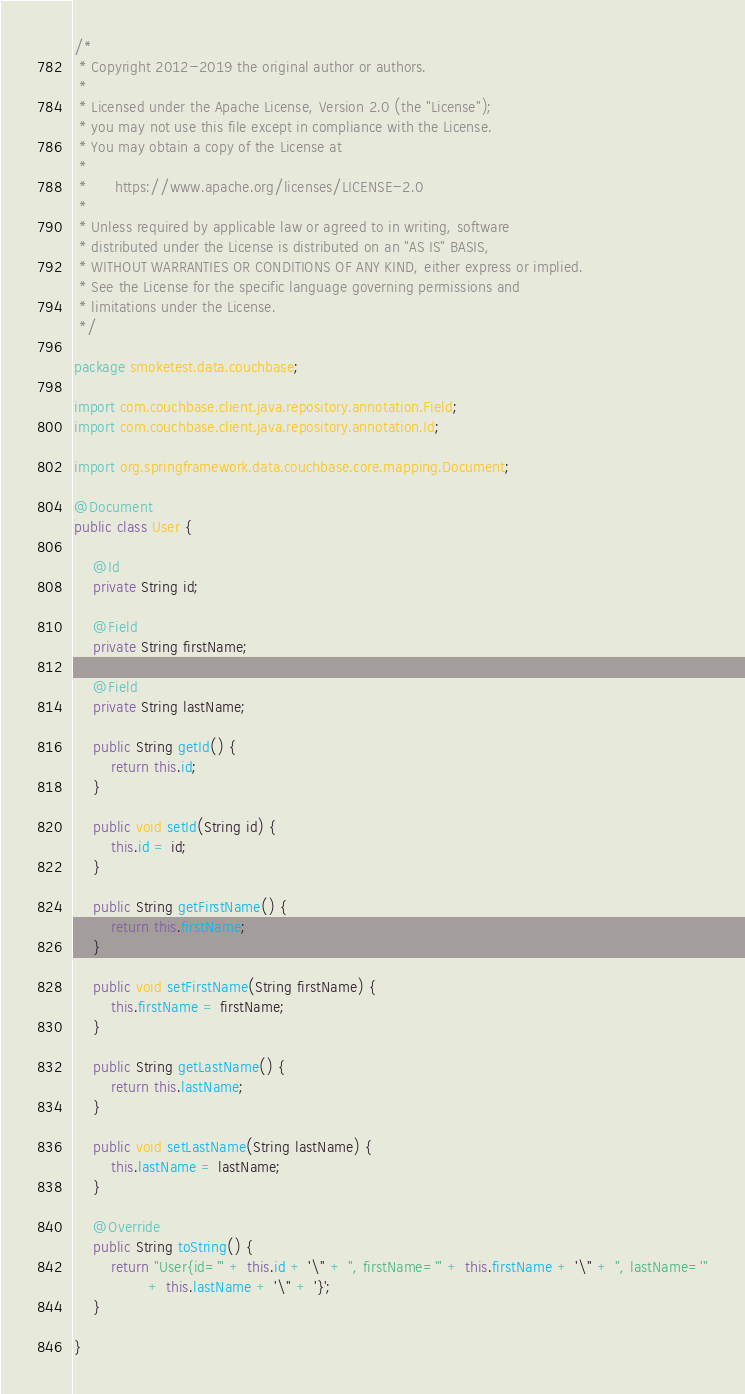<code> <loc_0><loc_0><loc_500><loc_500><_Java_>/*
 * Copyright 2012-2019 the original author or authors.
 *
 * Licensed under the Apache License, Version 2.0 (the "License");
 * you may not use this file except in compliance with the License.
 * You may obtain a copy of the License at
 *
 *      https://www.apache.org/licenses/LICENSE-2.0
 *
 * Unless required by applicable law or agreed to in writing, software
 * distributed under the License is distributed on an "AS IS" BASIS,
 * WITHOUT WARRANTIES OR CONDITIONS OF ANY KIND, either express or implied.
 * See the License for the specific language governing permissions and
 * limitations under the License.
 */

package smoketest.data.couchbase;

import com.couchbase.client.java.repository.annotation.Field;
import com.couchbase.client.java.repository.annotation.Id;

import org.springframework.data.couchbase.core.mapping.Document;

@Document
public class User {

	@Id
	private String id;

	@Field
	private String firstName;

	@Field
	private String lastName;

	public String getId() {
		return this.id;
	}

	public void setId(String id) {
		this.id = id;
	}

	public String getFirstName() {
		return this.firstName;
	}

	public void setFirstName(String firstName) {
		this.firstName = firstName;
	}

	public String getLastName() {
		return this.lastName;
	}

	public void setLastName(String lastName) {
		this.lastName = lastName;
	}

	@Override
	public String toString() {
		return "User{id='" + this.id + '\'' + ", firstName='" + this.firstName + '\'' + ", lastName='"
				+ this.lastName + '\'' + '}';
	}

}
</code> 